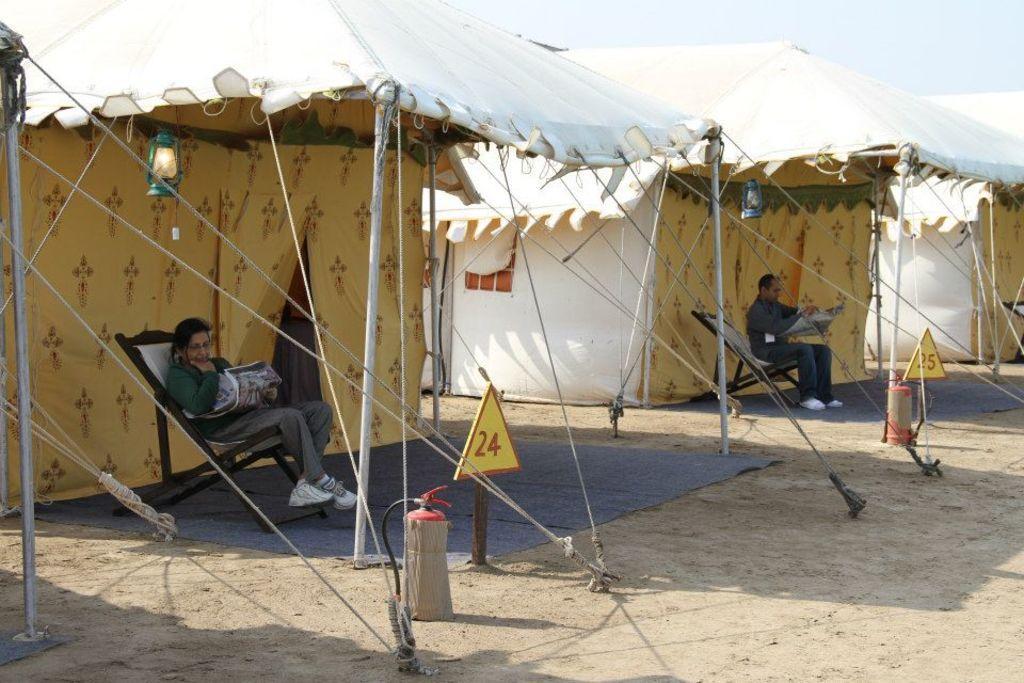How would you summarize this image in a sentence or two? In this image we can see a few tents, in front of the tents we can the people sitting on the chairs and reading newspapers, there are some poles, lamps, hydrants and boards with some numbers. 